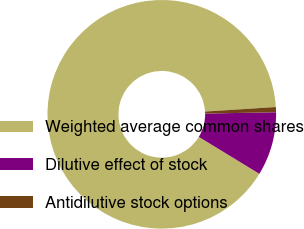Convert chart to OTSL. <chart><loc_0><loc_0><loc_500><loc_500><pie_chart><fcel>Weighted average common shares<fcel>Dilutive effect of stock<fcel>Antidilutive stock options<nl><fcel>90.27%<fcel>9.0%<fcel>0.73%<nl></chart> 